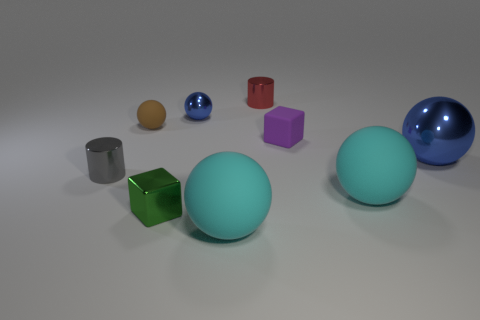Are there any large shiny balls? Yes, there are two large balls with a reflective surface that appear quite shiny. One is blue and the other is a sea-green color, both resting on a flat surface among various other geometric shapes in different colors and sizes. 